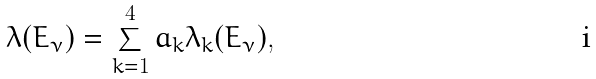Convert formula to latex. <formula><loc_0><loc_0><loc_500><loc_500>\lambda ( E _ { \nu } ) = \sum _ { k = 1 } ^ { 4 } a _ { k } \lambda _ { k } ( E _ { \nu } ) ,</formula> 